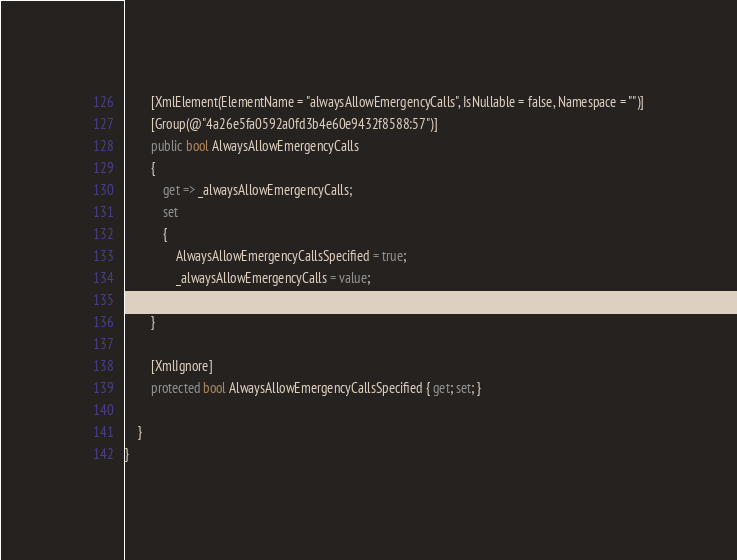Convert code to text. <code><loc_0><loc_0><loc_500><loc_500><_C#_>
        [XmlElement(ElementName = "alwaysAllowEmergencyCalls", IsNullable = false, Namespace = "")]
        [Group(@"4a26e5fa0592a0fd3b4e60e9432f8588:57")]
        public bool AlwaysAllowEmergencyCalls
        {
            get => _alwaysAllowEmergencyCalls;
            set
            {
                AlwaysAllowEmergencyCallsSpecified = true;
                _alwaysAllowEmergencyCalls = value;
            }
        }

        [XmlIgnore]
        protected bool AlwaysAllowEmergencyCallsSpecified { get; set; }

    }
}
</code> 